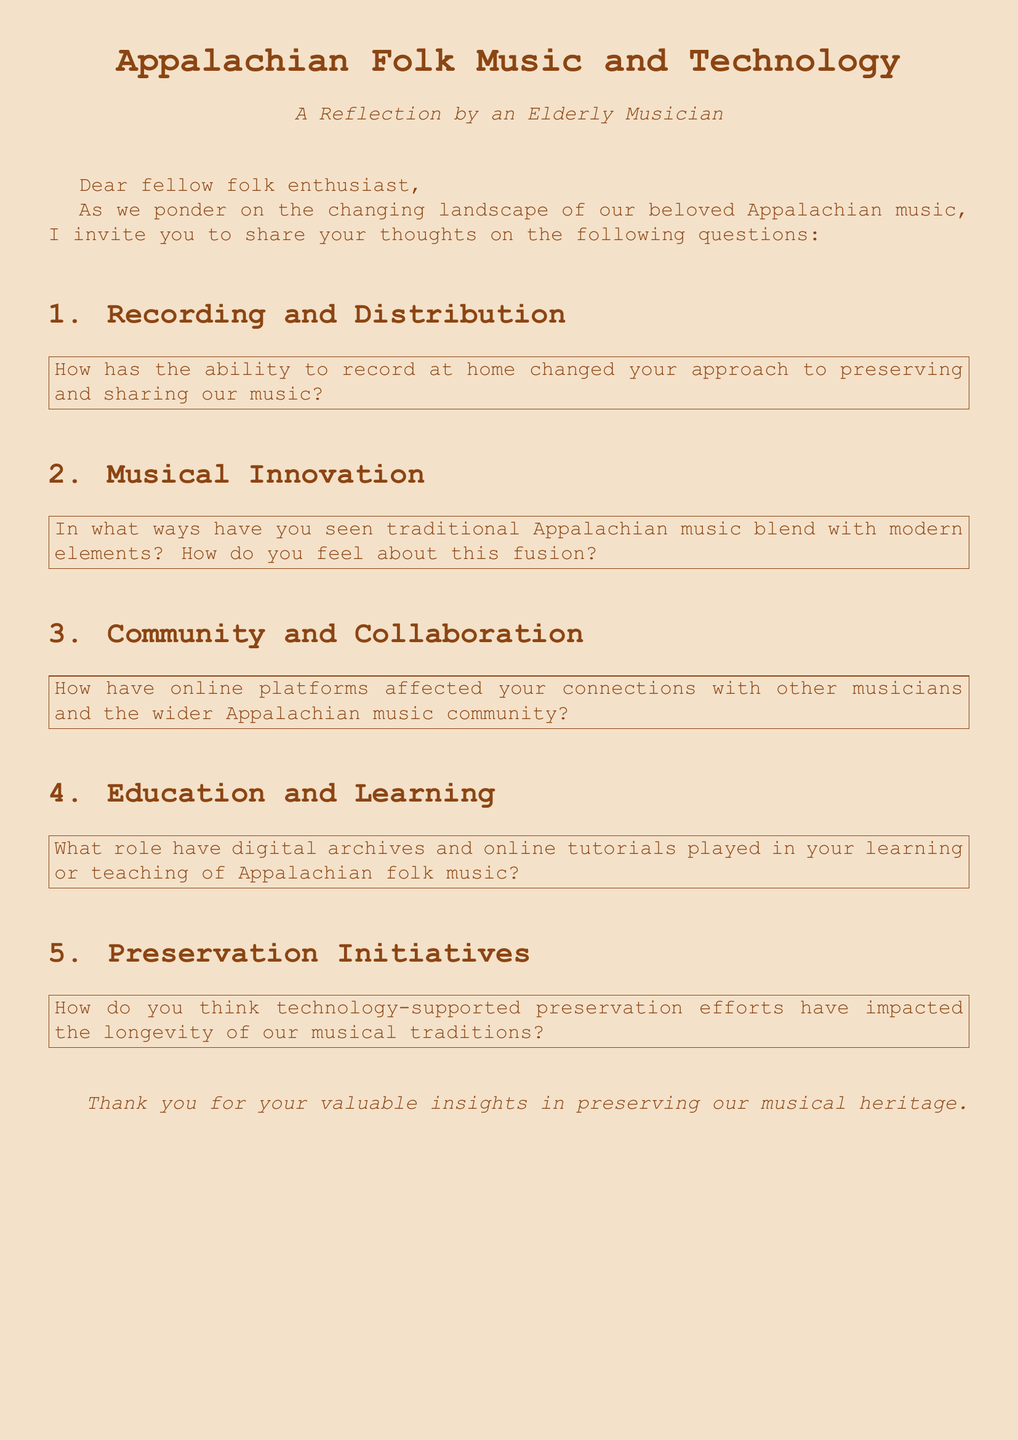What is the title of the document? The title of the document is presented at the top as "Appalachian Folk Music and Technology."
Answer: Appalachian Folk Music and Technology What is the focus of the reflection? The focus of the reflection is indicated in the introductory section where it mentions pondering the changing landscape of Appalachian music.
Answer: Changing landscape How many sections are there in the document? The document contains five sections, each addressing a specific aspect of the influence of technology.
Answer: Five What type of music is the document discussing? The type of music being discussed is identified in the title and throughout the text.
Answer: Appalachian folk music What is one method mentioned for preserving music? The document asks about the ability to record at home as a method for preserving music.
Answer: Recording at home How have online platforms been described in relation to musicians? The document asks how online platforms affect connections with other musicians, implying a positive influence.
Answer: Positive influence What role do digital archives play according to the questions? The document mentions digital archives in the context of their role in learning or teaching Appalachian folk music.
Answer: Learning and teaching How does the document invite responses from readers? The document invites responses from readers by stating, "I invite you to share your thoughts on the following questions."
Answer: Share your thoughts What color is used for the background of the document? The background color mentioned in the code is "parchment."
Answer: Parchment 